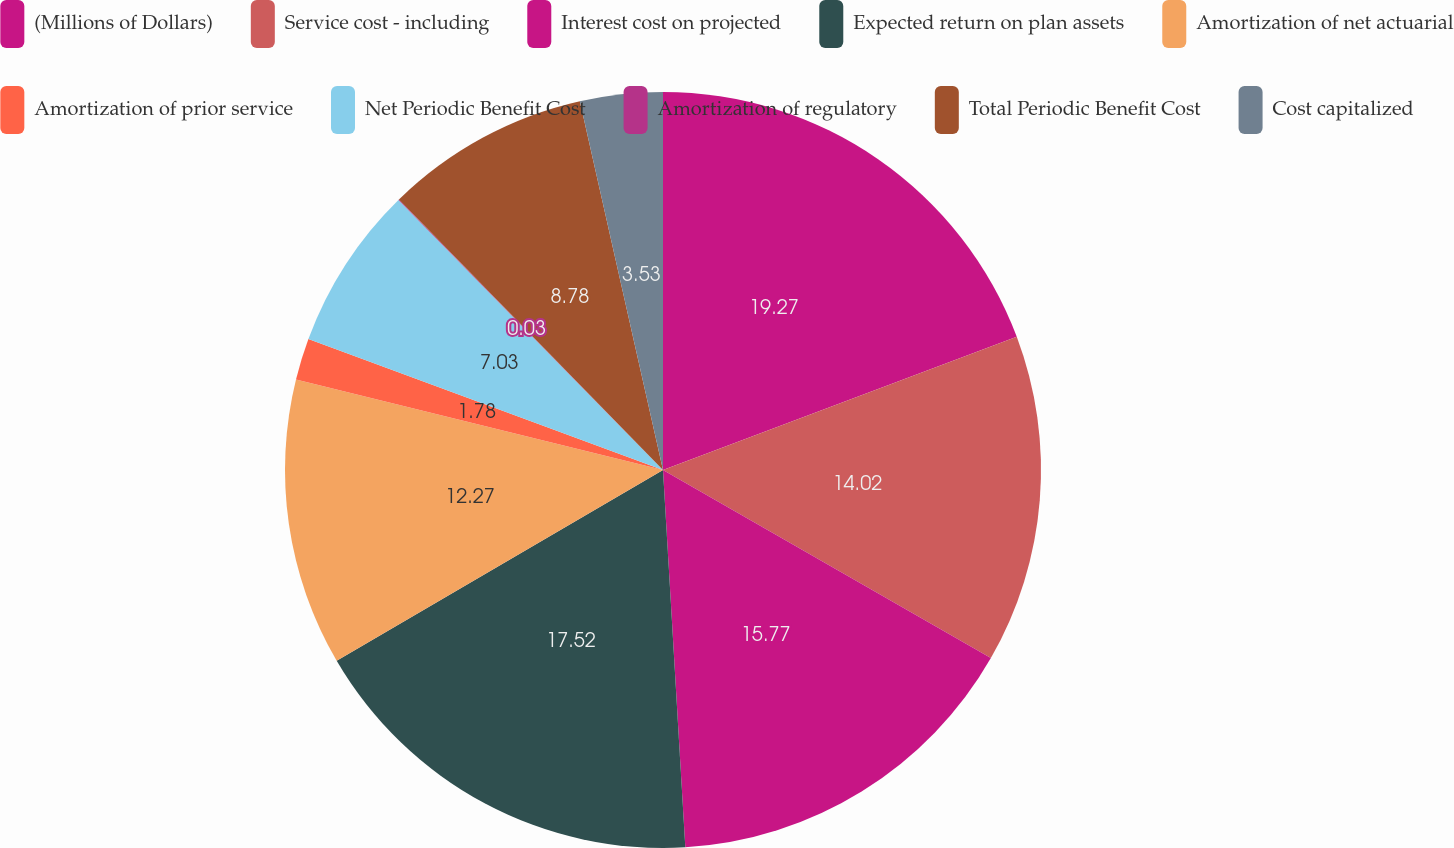Convert chart to OTSL. <chart><loc_0><loc_0><loc_500><loc_500><pie_chart><fcel>(Millions of Dollars)<fcel>Service cost - including<fcel>Interest cost on projected<fcel>Expected return on plan assets<fcel>Amortization of net actuarial<fcel>Amortization of prior service<fcel>Net Periodic Benefit Cost<fcel>Amortization of regulatory<fcel>Total Periodic Benefit Cost<fcel>Cost capitalized<nl><fcel>19.27%<fcel>14.02%<fcel>15.77%<fcel>17.52%<fcel>12.27%<fcel>1.78%<fcel>7.03%<fcel>0.03%<fcel>8.78%<fcel>3.53%<nl></chart> 